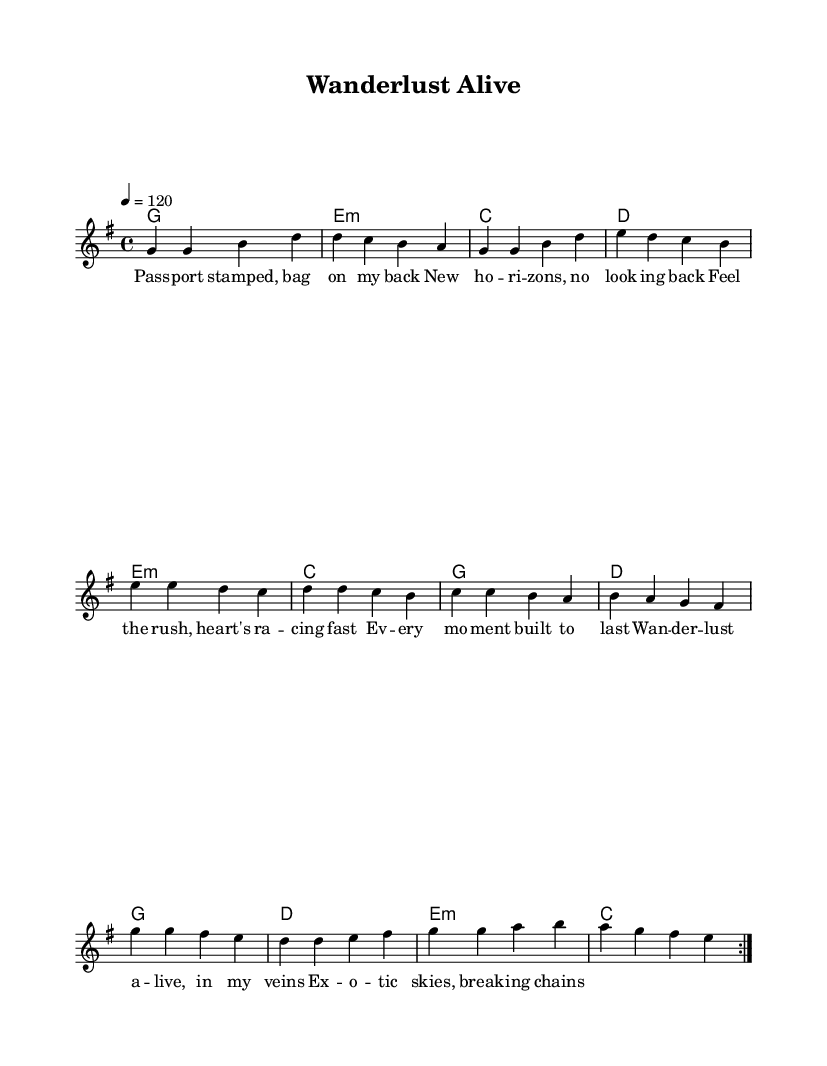What is the key signature of this music? The key signature is G major, which has one sharp (F#). This is indicated in the global settings of the score.
Answer: G major What is the time signature of the piece? The time signature is 4/4, which means there are four beats per measure. This is noted in the global settings of the score.
Answer: 4/4 What is the tempo of the piece? The tempo is indicated as 120 beats per minute. This is specified in the global settings of the score.
Answer: 120 How many measures are in the first repeated section? The first repeated section contains eight measures, which consists of the melody defined in the first volta. Counting each measure in the melody confirms this.
Answer: 8 What is the first lyric line of the song? The first lyric line is "Pass -- port stamped, bag on my back." This is given in the verse words section of the score.
Answer: Pass -- port stamped, bag on my back What type of chords are predominantly used in the harmonies? The predominant type of chords are major and minor chords, as indicated in the chord mode section of the score. This is identified by listing the chords and seeing they are primarily major and minor triads.
Answer: Major and minor What does the melody repeat before moving on to the next section? The melody repeats twice, as indicated by the "repeat volta 2" directive in the sheet music. This directs the performer to repeat the preceding section two times.
Answer: Twice 